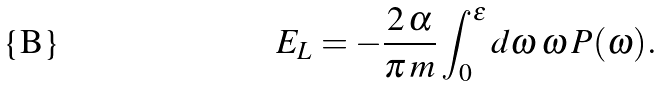Convert formula to latex. <formula><loc_0><loc_0><loc_500><loc_500>E _ { L } = - \frac { 2 \, \alpha } { \pi \, m } \int _ { 0 } ^ { \epsilon } d \omega \, \omega \, P ( \omega ) .</formula> 